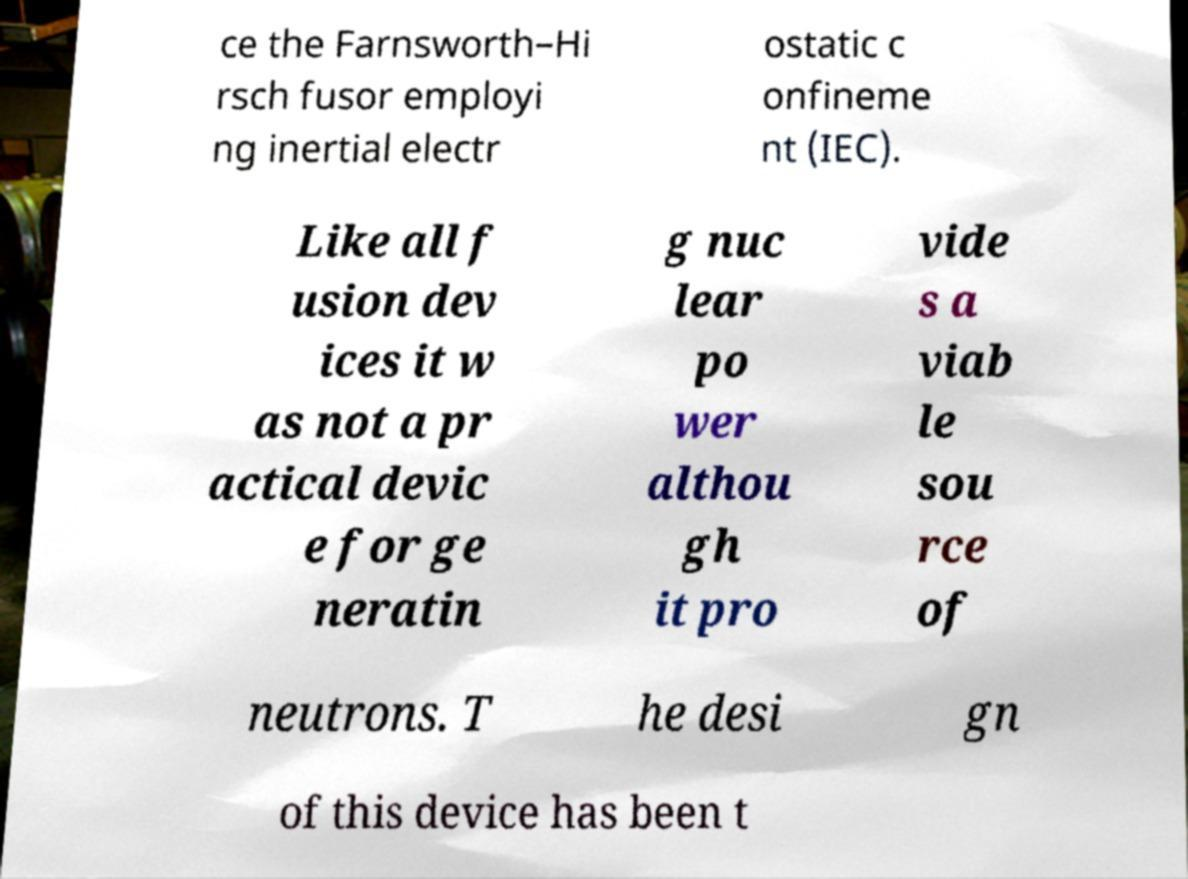Could you assist in decoding the text presented in this image and type it out clearly? ce the Farnsworth–Hi rsch fusor employi ng inertial electr ostatic c onfineme nt (IEC). Like all f usion dev ices it w as not a pr actical devic e for ge neratin g nuc lear po wer althou gh it pro vide s a viab le sou rce of neutrons. T he desi gn of this device has been t 